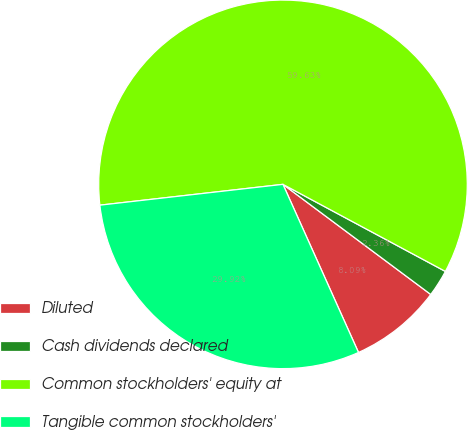Convert chart to OTSL. <chart><loc_0><loc_0><loc_500><loc_500><pie_chart><fcel>Diluted<fcel>Cash dividends declared<fcel>Common stockholders' equity at<fcel>Tangible common stockholders'<nl><fcel>8.09%<fcel>2.36%<fcel>59.64%<fcel>29.92%<nl></chart> 